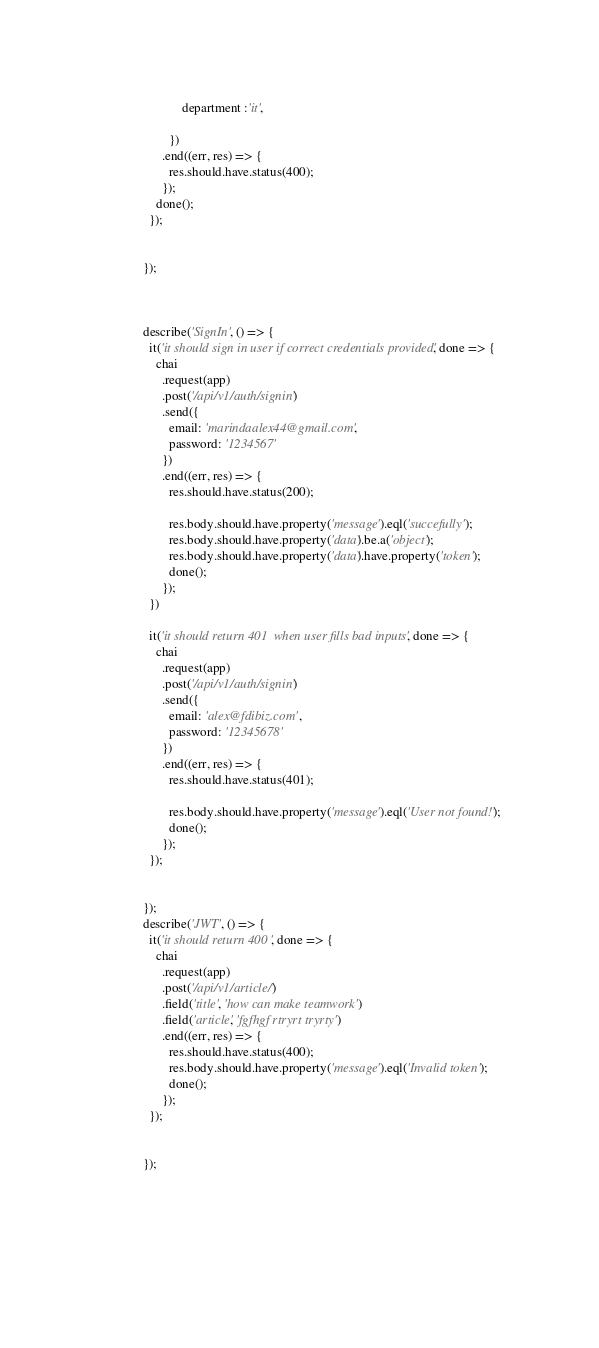<code> <loc_0><loc_0><loc_500><loc_500><_JavaScript_>              department :'it',
              
          })
        .end((err, res) => {
          res.should.have.status(400);
        });
      done();
    });


  });



  describe('SignIn', () => {
    it('it should sign in user if correct credentials provided', done => {
      chai
        .request(app)
        .post('/api/v1/auth/signin')
        .send({
          email: 'marindaalex44@gmail.com',
          password: '1234567'
        })
        .end((err, res) => {
          res.should.have.status(200);
         
          res.body.should.have.property('message').eql('succefully');
          res.body.should.have.property('data').be.a('object');
          res.body.should.have.property('data').have.property('token');
          done();
        });
    })

    it('it should return 401  when user fills bad inputs', done => {
      chai
        .request(app)
        .post('/api/v1/auth/signin')
        .send({
          email: 'alex@fdibiz.com',
          password: '12345678'
        })
        .end((err, res) => {
          res.should.have.status(401);
         
          res.body.should.have.property('message').eql('User not found!');
          done();
        });
    });


  });
  describe('JWT', () => {
    it('it should return 400 ', done => {
      chai
        .request(app)
        .post('/api/v1/article/')
        .field('title', 'how can make teamwork')
        .field('article', 'fgfhgf rtryrt tryrty')
        .end((err, res) => {
          res.should.have.status(400);
          res.body.should.have.property('message').eql('Invalid token');
          done();
        });
    });
 

  });




  


</code> 